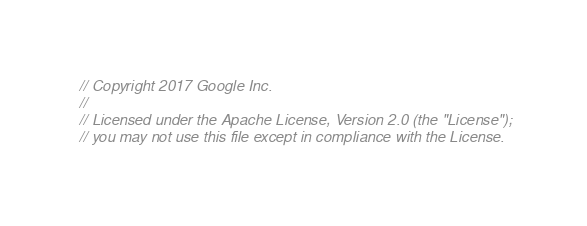<code> <loc_0><loc_0><loc_500><loc_500><_Java_>// Copyright 2017 Google Inc.
//
// Licensed under the Apache License, Version 2.0 (the "License");
// you may not use this file except in compliance with the License.</code> 